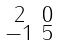Convert formula to latex. <formula><loc_0><loc_0><loc_500><loc_500>\begin{smallmatrix} 2 & 0 \\ - 1 & 5 \end{smallmatrix}</formula> 